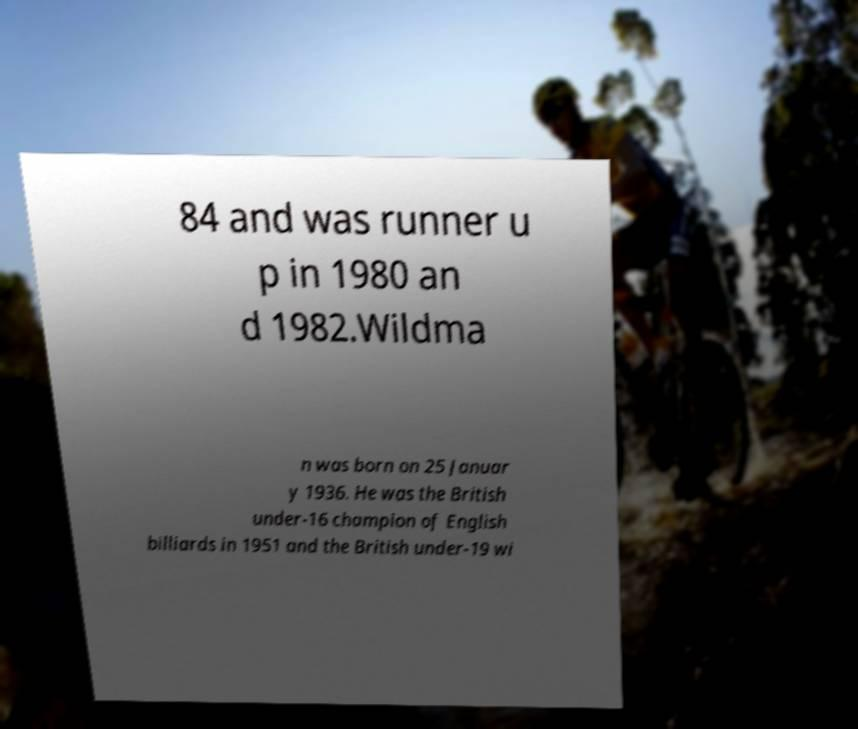What messages or text are displayed in this image? I need them in a readable, typed format. 84 and was runner u p in 1980 an d 1982.Wildma n was born on 25 Januar y 1936. He was the British under-16 champion of English billiards in 1951 and the British under-19 wi 